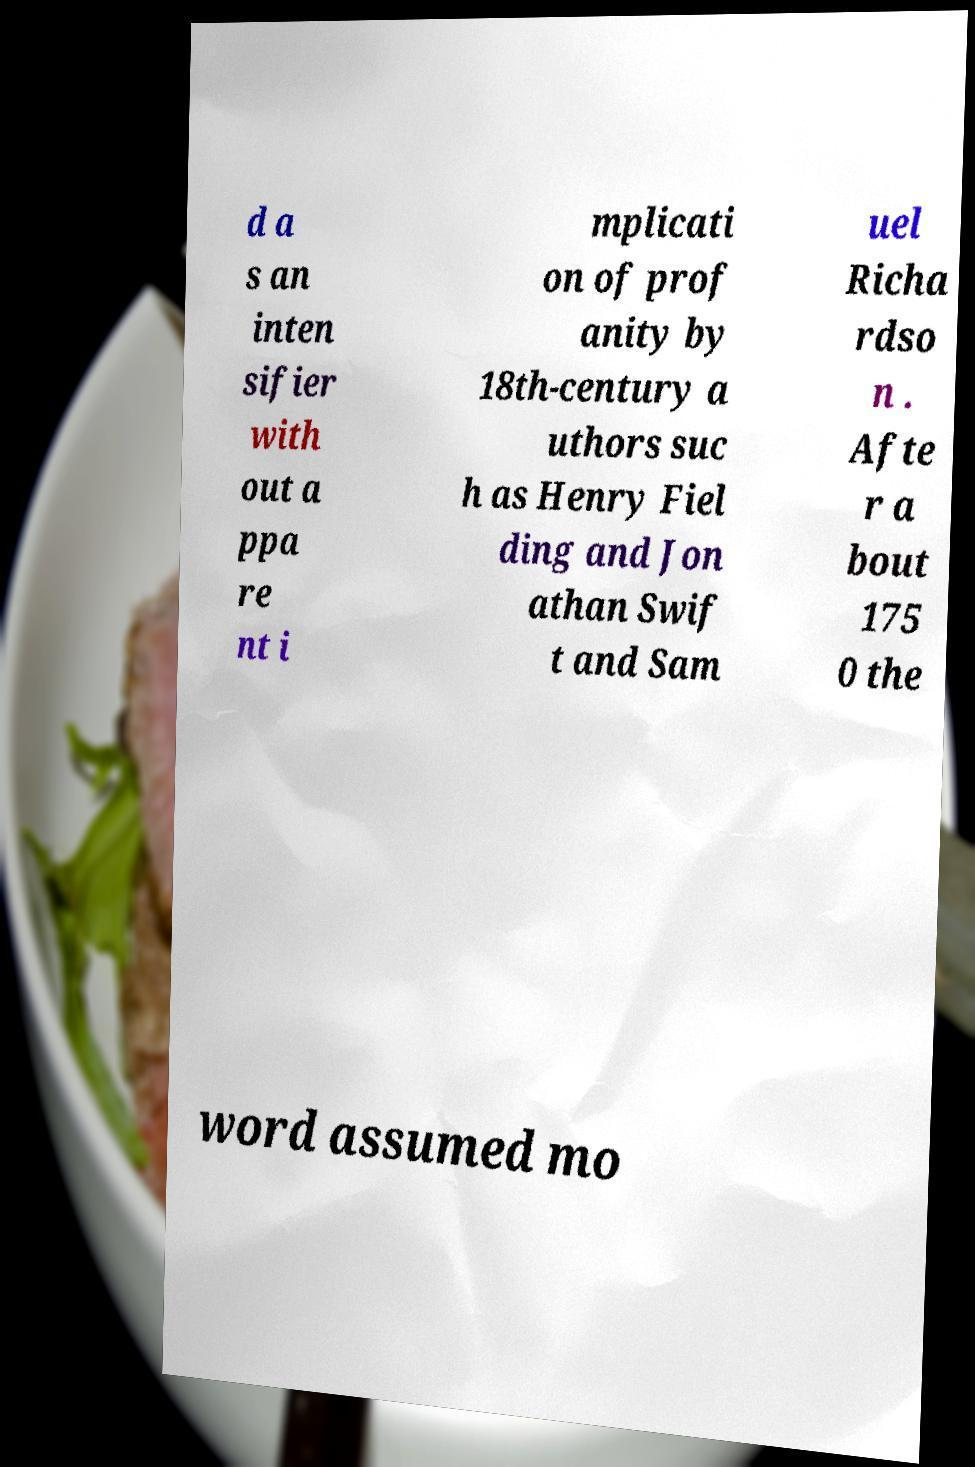Can you read and provide the text displayed in the image?This photo seems to have some interesting text. Can you extract and type it out for me? d a s an inten sifier with out a ppa re nt i mplicati on of prof anity by 18th-century a uthors suc h as Henry Fiel ding and Jon athan Swif t and Sam uel Richa rdso n . Afte r a bout 175 0 the word assumed mo 